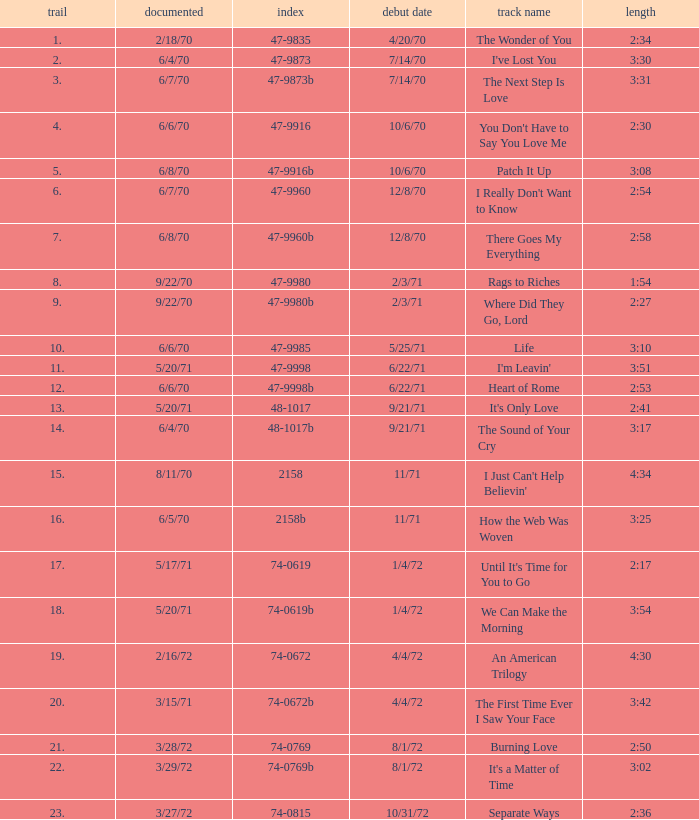What is the catalogue number for the song that is 3:17 and was released 9/21/71? 48-1017b. 